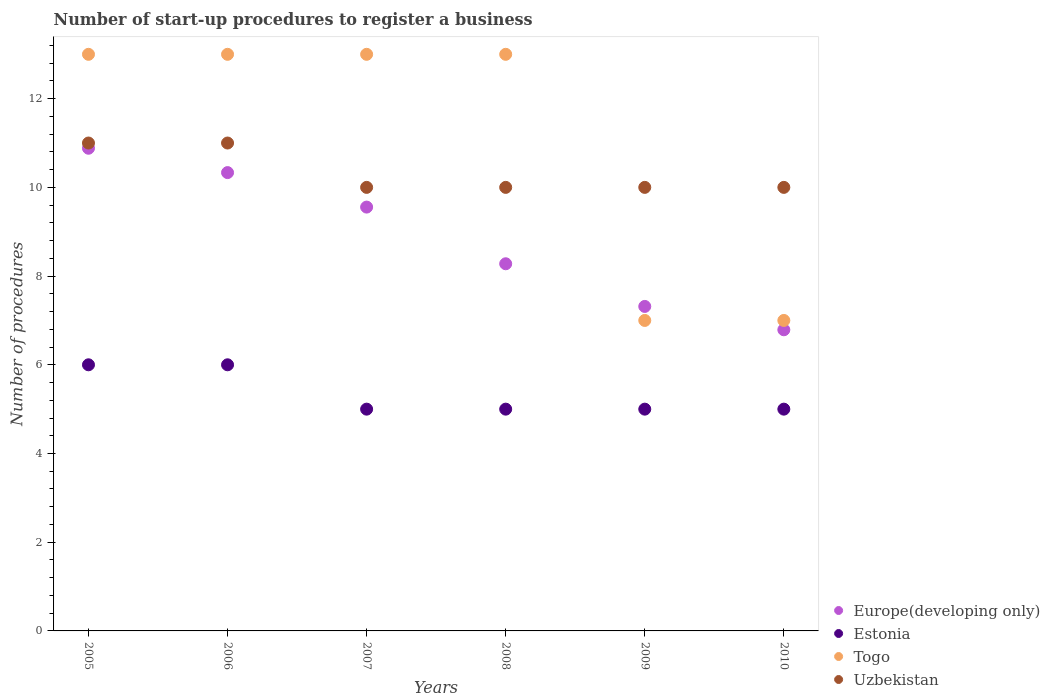Is the number of dotlines equal to the number of legend labels?
Keep it short and to the point. Yes. What is the number of procedures required to register a business in Uzbekistan in 2006?
Your answer should be compact. 11. Across all years, what is the maximum number of procedures required to register a business in Togo?
Your answer should be very brief. 13. Across all years, what is the minimum number of procedures required to register a business in Estonia?
Ensure brevity in your answer.  5. In which year was the number of procedures required to register a business in Uzbekistan maximum?
Keep it short and to the point. 2005. What is the total number of procedures required to register a business in Togo in the graph?
Give a very brief answer. 66. What is the difference between the number of procedures required to register a business in Estonia in 2008 and the number of procedures required to register a business in Europe(developing only) in 2007?
Offer a very short reply. -4.56. What is the average number of procedures required to register a business in Togo per year?
Provide a succinct answer. 11. In the year 2008, what is the difference between the number of procedures required to register a business in Togo and number of procedures required to register a business in Estonia?
Your response must be concise. 8. In how many years, is the number of procedures required to register a business in Europe(developing only) greater than 2.8?
Provide a succinct answer. 6. What is the ratio of the number of procedures required to register a business in Europe(developing only) in 2005 to that in 2008?
Give a very brief answer. 1.31. Is the number of procedures required to register a business in Estonia in 2008 less than that in 2009?
Provide a succinct answer. No. What is the difference between the highest and the second highest number of procedures required to register a business in Estonia?
Offer a very short reply. 0. What is the difference between the highest and the lowest number of procedures required to register a business in Europe(developing only)?
Make the answer very short. 4.09. Does the number of procedures required to register a business in Uzbekistan monotonically increase over the years?
Ensure brevity in your answer.  No. Is the number of procedures required to register a business in Togo strictly greater than the number of procedures required to register a business in Uzbekistan over the years?
Give a very brief answer. No. How many years are there in the graph?
Your response must be concise. 6. What is the difference between two consecutive major ticks on the Y-axis?
Offer a very short reply. 2. Are the values on the major ticks of Y-axis written in scientific E-notation?
Offer a very short reply. No. Where does the legend appear in the graph?
Your response must be concise. Bottom right. How many legend labels are there?
Keep it short and to the point. 4. What is the title of the graph?
Keep it short and to the point. Number of start-up procedures to register a business. Does "Faeroe Islands" appear as one of the legend labels in the graph?
Your answer should be very brief. No. What is the label or title of the X-axis?
Ensure brevity in your answer.  Years. What is the label or title of the Y-axis?
Your answer should be compact. Number of procedures. What is the Number of procedures of Europe(developing only) in 2005?
Provide a succinct answer. 10.88. What is the Number of procedures in Estonia in 2005?
Offer a terse response. 6. What is the Number of procedures of Uzbekistan in 2005?
Make the answer very short. 11. What is the Number of procedures of Europe(developing only) in 2006?
Offer a terse response. 10.33. What is the Number of procedures of Estonia in 2006?
Provide a succinct answer. 6. What is the Number of procedures in Uzbekistan in 2006?
Provide a succinct answer. 11. What is the Number of procedures of Europe(developing only) in 2007?
Offer a very short reply. 9.56. What is the Number of procedures in Estonia in 2007?
Ensure brevity in your answer.  5. What is the Number of procedures of Togo in 2007?
Offer a terse response. 13. What is the Number of procedures of Uzbekistan in 2007?
Keep it short and to the point. 10. What is the Number of procedures in Europe(developing only) in 2008?
Offer a terse response. 8.28. What is the Number of procedures in Europe(developing only) in 2009?
Provide a succinct answer. 7.32. What is the Number of procedures in Estonia in 2009?
Provide a succinct answer. 5. What is the Number of procedures of Togo in 2009?
Give a very brief answer. 7. What is the Number of procedures in Uzbekistan in 2009?
Offer a terse response. 10. What is the Number of procedures in Europe(developing only) in 2010?
Ensure brevity in your answer.  6.79. What is the Number of procedures in Estonia in 2010?
Your answer should be very brief. 5. What is the Number of procedures of Togo in 2010?
Keep it short and to the point. 7. Across all years, what is the maximum Number of procedures in Europe(developing only)?
Ensure brevity in your answer.  10.88. Across all years, what is the maximum Number of procedures in Estonia?
Offer a terse response. 6. Across all years, what is the maximum Number of procedures in Togo?
Keep it short and to the point. 13. Across all years, what is the minimum Number of procedures of Europe(developing only)?
Your answer should be compact. 6.79. Across all years, what is the minimum Number of procedures of Togo?
Provide a short and direct response. 7. What is the total Number of procedures of Europe(developing only) in the graph?
Keep it short and to the point. 53.15. What is the total Number of procedures of Togo in the graph?
Make the answer very short. 66. What is the difference between the Number of procedures of Europe(developing only) in 2005 and that in 2006?
Make the answer very short. 0.55. What is the difference between the Number of procedures of Estonia in 2005 and that in 2006?
Offer a very short reply. 0. What is the difference between the Number of procedures of Togo in 2005 and that in 2006?
Your response must be concise. 0. What is the difference between the Number of procedures of Europe(developing only) in 2005 and that in 2007?
Provide a short and direct response. 1.33. What is the difference between the Number of procedures of Europe(developing only) in 2005 and that in 2008?
Provide a short and direct response. 2.6. What is the difference between the Number of procedures in Togo in 2005 and that in 2008?
Your answer should be very brief. 0. What is the difference between the Number of procedures of Europe(developing only) in 2005 and that in 2009?
Your answer should be compact. 3.57. What is the difference between the Number of procedures in Uzbekistan in 2005 and that in 2009?
Offer a very short reply. 1. What is the difference between the Number of procedures of Europe(developing only) in 2005 and that in 2010?
Ensure brevity in your answer.  4.09. What is the difference between the Number of procedures of Uzbekistan in 2005 and that in 2010?
Give a very brief answer. 1. What is the difference between the Number of procedures of Togo in 2006 and that in 2007?
Give a very brief answer. 0. What is the difference between the Number of procedures of Uzbekistan in 2006 and that in 2007?
Make the answer very short. 1. What is the difference between the Number of procedures in Europe(developing only) in 2006 and that in 2008?
Your response must be concise. 2.06. What is the difference between the Number of procedures in Togo in 2006 and that in 2008?
Your answer should be very brief. 0. What is the difference between the Number of procedures of Europe(developing only) in 2006 and that in 2009?
Your response must be concise. 3.02. What is the difference between the Number of procedures of Estonia in 2006 and that in 2009?
Offer a very short reply. 1. What is the difference between the Number of procedures of Europe(developing only) in 2006 and that in 2010?
Offer a very short reply. 3.54. What is the difference between the Number of procedures of Togo in 2006 and that in 2010?
Offer a very short reply. 6. What is the difference between the Number of procedures in Europe(developing only) in 2007 and that in 2008?
Offer a very short reply. 1.28. What is the difference between the Number of procedures of Estonia in 2007 and that in 2008?
Offer a very short reply. 0. What is the difference between the Number of procedures of Uzbekistan in 2007 and that in 2008?
Provide a short and direct response. 0. What is the difference between the Number of procedures in Europe(developing only) in 2007 and that in 2009?
Give a very brief answer. 2.24. What is the difference between the Number of procedures of Uzbekistan in 2007 and that in 2009?
Make the answer very short. 0. What is the difference between the Number of procedures in Europe(developing only) in 2007 and that in 2010?
Your response must be concise. 2.77. What is the difference between the Number of procedures of Togo in 2007 and that in 2010?
Offer a very short reply. 6. What is the difference between the Number of procedures in Europe(developing only) in 2008 and that in 2009?
Offer a terse response. 0.96. What is the difference between the Number of procedures in Estonia in 2008 and that in 2009?
Offer a terse response. 0. What is the difference between the Number of procedures of Togo in 2008 and that in 2009?
Your answer should be compact. 6. What is the difference between the Number of procedures in Europe(developing only) in 2008 and that in 2010?
Keep it short and to the point. 1.49. What is the difference between the Number of procedures of Estonia in 2008 and that in 2010?
Offer a terse response. 0. What is the difference between the Number of procedures in Togo in 2008 and that in 2010?
Your response must be concise. 6. What is the difference between the Number of procedures in Uzbekistan in 2008 and that in 2010?
Provide a short and direct response. 0. What is the difference between the Number of procedures in Europe(developing only) in 2009 and that in 2010?
Provide a short and direct response. 0.53. What is the difference between the Number of procedures of Uzbekistan in 2009 and that in 2010?
Make the answer very short. 0. What is the difference between the Number of procedures in Europe(developing only) in 2005 and the Number of procedures in Estonia in 2006?
Offer a very short reply. 4.88. What is the difference between the Number of procedures in Europe(developing only) in 2005 and the Number of procedures in Togo in 2006?
Your answer should be compact. -2.12. What is the difference between the Number of procedures of Europe(developing only) in 2005 and the Number of procedures of Uzbekistan in 2006?
Keep it short and to the point. -0.12. What is the difference between the Number of procedures of Estonia in 2005 and the Number of procedures of Togo in 2006?
Offer a terse response. -7. What is the difference between the Number of procedures in Estonia in 2005 and the Number of procedures in Uzbekistan in 2006?
Ensure brevity in your answer.  -5. What is the difference between the Number of procedures in Togo in 2005 and the Number of procedures in Uzbekistan in 2006?
Provide a succinct answer. 2. What is the difference between the Number of procedures of Europe(developing only) in 2005 and the Number of procedures of Estonia in 2007?
Keep it short and to the point. 5.88. What is the difference between the Number of procedures in Europe(developing only) in 2005 and the Number of procedures in Togo in 2007?
Make the answer very short. -2.12. What is the difference between the Number of procedures in Europe(developing only) in 2005 and the Number of procedures in Uzbekistan in 2007?
Ensure brevity in your answer.  0.88. What is the difference between the Number of procedures of Estonia in 2005 and the Number of procedures of Uzbekistan in 2007?
Your answer should be very brief. -4. What is the difference between the Number of procedures of Togo in 2005 and the Number of procedures of Uzbekistan in 2007?
Your answer should be very brief. 3. What is the difference between the Number of procedures of Europe(developing only) in 2005 and the Number of procedures of Estonia in 2008?
Provide a succinct answer. 5.88. What is the difference between the Number of procedures of Europe(developing only) in 2005 and the Number of procedures of Togo in 2008?
Your response must be concise. -2.12. What is the difference between the Number of procedures of Europe(developing only) in 2005 and the Number of procedures of Uzbekistan in 2008?
Keep it short and to the point. 0.88. What is the difference between the Number of procedures in Estonia in 2005 and the Number of procedures in Togo in 2008?
Your response must be concise. -7. What is the difference between the Number of procedures of Estonia in 2005 and the Number of procedures of Uzbekistan in 2008?
Provide a short and direct response. -4. What is the difference between the Number of procedures in Togo in 2005 and the Number of procedures in Uzbekistan in 2008?
Your answer should be very brief. 3. What is the difference between the Number of procedures of Europe(developing only) in 2005 and the Number of procedures of Estonia in 2009?
Provide a short and direct response. 5.88. What is the difference between the Number of procedures in Europe(developing only) in 2005 and the Number of procedures in Togo in 2009?
Make the answer very short. 3.88. What is the difference between the Number of procedures in Europe(developing only) in 2005 and the Number of procedures in Uzbekistan in 2009?
Ensure brevity in your answer.  0.88. What is the difference between the Number of procedures in Estonia in 2005 and the Number of procedures in Togo in 2009?
Your answer should be compact. -1. What is the difference between the Number of procedures in Europe(developing only) in 2005 and the Number of procedures in Estonia in 2010?
Your response must be concise. 5.88. What is the difference between the Number of procedures in Europe(developing only) in 2005 and the Number of procedures in Togo in 2010?
Provide a succinct answer. 3.88. What is the difference between the Number of procedures of Europe(developing only) in 2005 and the Number of procedures of Uzbekistan in 2010?
Your answer should be compact. 0.88. What is the difference between the Number of procedures in Estonia in 2005 and the Number of procedures in Togo in 2010?
Offer a terse response. -1. What is the difference between the Number of procedures in Estonia in 2005 and the Number of procedures in Uzbekistan in 2010?
Offer a terse response. -4. What is the difference between the Number of procedures of Togo in 2005 and the Number of procedures of Uzbekistan in 2010?
Your answer should be compact. 3. What is the difference between the Number of procedures in Europe(developing only) in 2006 and the Number of procedures in Estonia in 2007?
Keep it short and to the point. 5.33. What is the difference between the Number of procedures of Europe(developing only) in 2006 and the Number of procedures of Togo in 2007?
Your response must be concise. -2.67. What is the difference between the Number of procedures of Estonia in 2006 and the Number of procedures of Uzbekistan in 2007?
Your answer should be compact. -4. What is the difference between the Number of procedures of Togo in 2006 and the Number of procedures of Uzbekistan in 2007?
Provide a short and direct response. 3. What is the difference between the Number of procedures in Europe(developing only) in 2006 and the Number of procedures in Estonia in 2008?
Make the answer very short. 5.33. What is the difference between the Number of procedures of Europe(developing only) in 2006 and the Number of procedures of Togo in 2008?
Ensure brevity in your answer.  -2.67. What is the difference between the Number of procedures in Estonia in 2006 and the Number of procedures in Togo in 2008?
Offer a very short reply. -7. What is the difference between the Number of procedures of Togo in 2006 and the Number of procedures of Uzbekistan in 2008?
Your response must be concise. 3. What is the difference between the Number of procedures of Europe(developing only) in 2006 and the Number of procedures of Estonia in 2009?
Provide a succinct answer. 5.33. What is the difference between the Number of procedures in Estonia in 2006 and the Number of procedures in Togo in 2009?
Offer a terse response. -1. What is the difference between the Number of procedures of Europe(developing only) in 2006 and the Number of procedures of Estonia in 2010?
Your answer should be very brief. 5.33. What is the difference between the Number of procedures of Europe(developing only) in 2006 and the Number of procedures of Uzbekistan in 2010?
Offer a terse response. 0.33. What is the difference between the Number of procedures of Estonia in 2006 and the Number of procedures of Togo in 2010?
Keep it short and to the point. -1. What is the difference between the Number of procedures of Europe(developing only) in 2007 and the Number of procedures of Estonia in 2008?
Give a very brief answer. 4.56. What is the difference between the Number of procedures of Europe(developing only) in 2007 and the Number of procedures of Togo in 2008?
Your answer should be very brief. -3.44. What is the difference between the Number of procedures in Europe(developing only) in 2007 and the Number of procedures in Uzbekistan in 2008?
Your answer should be compact. -0.44. What is the difference between the Number of procedures of Estonia in 2007 and the Number of procedures of Togo in 2008?
Ensure brevity in your answer.  -8. What is the difference between the Number of procedures of Estonia in 2007 and the Number of procedures of Uzbekistan in 2008?
Provide a succinct answer. -5. What is the difference between the Number of procedures in Europe(developing only) in 2007 and the Number of procedures in Estonia in 2009?
Your answer should be compact. 4.56. What is the difference between the Number of procedures in Europe(developing only) in 2007 and the Number of procedures in Togo in 2009?
Offer a very short reply. 2.56. What is the difference between the Number of procedures in Europe(developing only) in 2007 and the Number of procedures in Uzbekistan in 2009?
Provide a succinct answer. -0.44. What is the difference between the Number of procedures of Estonia in 2007 and the Number of procedures of Uzbekistan in 2009?
Your answer should be compact. -5. What is the difference between the Number of procedures in Europe(developing only) in 2007 and the Number of procedures in Estonia in 2010?
Your response must be concise. 4.56. What is the difference between the Number of procedures of Europe(developing only) in 2007 and the Number of procedures of Togo in 2010?
Offer a very short reply. 2.56. What is the difference between the Number of procedures in Europe(developing only) in 2007 and the Number of procedures in Uzbekistan in 2010?
Your response must be concise. -0.44. What is the difference between the Number of procedures in Estonia in 2007 and the Number of procedures in Togo in 2010?
Give a very brief answer. -2. What is the difference between the Number of procedures of Togo in 2007 and the Number of procedures of Uzbekistan in 2010?
Offer a terse response. 3. What is the difference between the Number of procedures in Europe(developing only) in 2008 and the Number of procedures in Estonia in 2009?
Your answer should be very brief. 3.28. What is the difference between the Number of procedures of Europe(developing only) in 2008 and the Number of procedures of Togo in 2009?
Provide a short and direct response. 1.28. What is the difference between the Number of procedures of Europe(developing only) in 2008 and the Number of procedures of Uzbekistan in 2009?
Your answer should be compact. -1.72. What is the difference between the Number of procedures of Estonia in 2008 and the Number of procedures of Uzbekistan in 2009?
Make the answer very short. -5. What is the difference between the Number of procedures in Togo in 2008 and the Number of procedures in Uzbekistan in 2009?
Make the answer very short. 3. What is the difference between the Number of procedures of Europe(developing only) in 2008 and the Number of procedures of Estonia in 2010?
Your answer should be compact. 3.28. What is the difference between the Number of procedures of Europe(developing only) in 2008 and the Number of procedures of Togo in 2010?
Your answer should be compact. 1.28. What is the difference between the Number of procedures of Europe(developing only) in 2008 and the Number of procedures of Uzbekistan in 2010?
Your answer should be compact. -1.72. What is the difference between the Number of procedures of Estonia in 2008 and the Number of procedures of Togo in 2010?
Keep it short and to the point. -2. What is the difference between the Number of procedures in Togo in 2008 and the Number of procedures in Uzbekistan in 2010?
Provide a succinct answer. 3. What is the difference between the Number of procedures in Europe(developing only) in 2009 and the Number of procedures in Estonia in 2010?
Your answer should be very brief. 2.32. What is the difference between the Number of procedures of Europe(developing only) in 2009 and the Number of procedures of Togo in 2010?
Keep it short and to the point. 0.32. What is the difference between the Number of procedures in Europe(developing only) in 2009 and the Number of procedures in Uzbekistan in 2010?
Provide a succinct answer. -2.68. What is the difference between the Number of procedures in Estonia in 2009 and the Number of procedures in Togo in 2010?
Make the answer very short. -2. What is the difference between the Number of procedures in Estonia in 2009 and the Number of procedures in Uzbekistan in 2010?
Offer a very short reply. -5. What is the difference between the Number of procedures of Togo in 2009 and the Number of procedures of Uzbekistan in 2010?
Provide a short and direct response. -3. What is the average Number of procedures of Europe(developing only) per year?
Your answer should be very brief. 8.86. What is the average Number of procedures in Estonia per year?
Keep it short and to the point. 5.33. What is the average Number of procedures in Uzbekistan per year?
Your answer should be very brief. 10.33. In the year 2005, what is the difference between the Number of procedures in Europe(developing only) and Number of procedures in Estonia?
Your answer should be compact. 4.88. In the year 2005, what is the difference between the Number of procedures of Europe(developing only) and Number of procedures of Togo?
Keep it short and to the point. -2.12. In the year 2005, what is the difference between the Number of procedures in Europe(developing only) and Number of procedures in Uzbekistan?
Ensure brevity in your answer.  -0.12. In the year 2005, what is the difference between the Number of procedures of Estonia and Number of procedures of Togo?
Your answer should be compact. -7. In the year 2005, what is the difference between the Number of procedures in Togo and Number of procedures in Uzbekistan?
Provide a succinct answer. 2. In the year 2006, what is the difference between the Number of procedures of Europe(developing only) and Number of procedures of Estonia?
Offer a very short reply. 4.33. In the year 2006, what is the difference between the Number of procedures in Europe(developing only) and Number of procedures in Togo?
Your answer should be compact. -2.67. In the year 2006, what is the difference between the Number of procedures in Estonia and Number of procedures in Togo?
Provide a short and direct response. -7. In the year 2006, what is the difference between the Number of procedures of Estonia and Number of procedures of Uzbekistan?
Offer a terse response. -5. In the year 2006, what is the difference between the Number of procedures of Togo and Number of procedures of Uzbekistan?
Ensure brevity in your answer.  2. In the year 2007, what is the difference between the Number of procedures of Europe(developing only) and Number of procedures of Estonia?
Your answer should be compact. 4.56. In the year 2007, what is the difference between the Number of procedures in Europe(developing only) and Number of procedures in Togo?
Keep it short and to the point. -3.44. In the year 2007, what is the difference between the Number of procedures in Europe(developing only) and Number of procedures in Uzbekistan?
Provide a succinct answer. -0.44. In the year 2008, what is the difference between the Number of procedures of Europe(developing only) and Number of procedures of Estonia?
Ensure brevity in your answer.  3.28. In the year 2008, what is the difference between the Number of procedures in Europe(developing only) and Number of procedures in Togo?
Your answer should be compact. -4.72. In the year 2008, what is the difference between the Number of procedures of Europe(developing only) and Number of procedures of Uzbekistan?
Offer a very short reply. -1.72. In the year 2008, what is the difference between the Number of procedures of Estonia and Number of procedures of Togo?
Your answer should be compact. -8. In the year 2008, what is the difference between the Number of procedures in Togo and Number of procedures in Uzbekistan?
Provide a short and direct response. 3. In the year 2009, what is the difference between the Number of procedures of Europe(developing only) and Number of procedures of Estonia?
Your answer should be compact. 2.32. In the year 2009, what is the difference between the Number of procedures of Europe(developing only) and Number of procedures of Togo?
Your answer should be compact. 0.32. In the year 2009, what is the difference between the Number of procedures in Europe(developing only) and Number of procedures in Uzbekistan?
Provide a short and direct response. -2.68. In the year 2009, what is the difference between the Number of procedures of Estonia and Number of procedures of Uzbekistan?
Offer a very short reply. -5. In the year 2009, what is the difference between the Number of procedures in Togo and Number of procedures in Uzbekistan?
Provide a succinct answer. -3. In the year 2010, what is the difference between the Number of procedures in Europe(developing only) and Number of procedures in Estonia?
Make the answer very short. 1.79. In the year 2010, what is the difference between the Number of procedures of Europe(developing only) and Number of procedures of Togo?
Provide a succinct answer. -0.21. In the year 2010, what is the difference between the Number of procedures of Europe(developing only) and Number of procedures of Uzbekistan?
Your response must be concise. -3.21. In the year 2010, what is the difference between the Number of procedures in Estonia and Number of procedures in Togo?
Your response must be concise. -2. What is the ratio of the Number of procedures in Europe(developing only) in 2005 to that in 2006?
Offer a terse response. 1.05. What is the ratio of the Number of procedures in Togo in 2005 to that in 2006?
Offer a terse response. 1. What is the ratio of the Number of procedures of Uzbekistan in 2005 to that in 2006?
Your answer should be compact. 1. What is the ratio of the Number of procedures of Europe(developing only) in 2005 to that in 2007?
Your response must be concise. 1.14. What is the ratio of the Number of procedures of Europe(developing only) in 2005 to that in 2008?
Your answer should be compact. 1.31. What is the ratio of the Number of procedures in Europe(developing only) in 2005 to that in 2009?
Keep it short and to the point. 1.49. What is the ratio of the Number of procedures in Togo in 2005 to that in 2009?
Provide a short and direct response. 1.86. What is the ratio of the Number of procedures in Uzbekistan in 2005 to that in 2009?
Your answer should be compact. 1.1. What is the ratio of the Number of procedures of Europe(developing only) in 2005 to that in 2010?
Your answer should be very brief. 1.6. What is the ratio of the Number of procedures in Togo in 2005 to that in 2010?
Give a very brief answer. 1.86. What is the ratio of the Number of procedures of Uzbekistan in 2005 to that in 2010?
Provide a short and direct response. 1.1. What is the ratio of the Number of procedures in Europe(developing only) in 2006 to that in 2007?
Your response must be concise. 1.08. What is the ratio of the Number of procedures of Estonia in 2006 to that in 2007?
Provide a succinct answer. 1.2. What is the ratio of the Number of procedures in Uzbekistan in 2006 to that in 2007?
Your answer should be compact. 1.1. What is the ratio of the Number of procedures in Europe(developing only) in 2006 to that in 2008?
Your response must be concise. 1.25. What is the ratio of the Number of procedures in Europe(developing only) in 2006 to that in 2009?
Your response must be concise. 1.41. What is the ratio of the Number of procedures in Togo in 2006 to that in 2009?
Your answer should be compact. 1.86. What is the ratio of the Number of procedures of Uzbekistan in 2006 to that in 2009?
Offer a terse response. 1.1. What is the ratio of the Number of procedures of Europe(developing only) in 2006 to that in 2010?
Your answer should be very brief. 1.52. What is the ratio of the Number of procedures of Togo in 2006 to that in 2010?
Make the answer very short. 1.86. What is the ratio of the Number of procedures in Uzbekistan in 2006 to that in 2010?
Provide a short and direct response. 1.1. What is the ratio of the Number of procedures in Europe(developing only) in 2007 to that in 2008?
Keep it short and to the point. 1.15. What is the ratio of the Number of procedures in Estonia in 2007 to that in 2008?
Make the answer very short. 1. What is the ratio of the Number of procedures of Europe(developing only) in 2007 to that in 2009?
Give a very brief answer. 1.31. What is the ratio of the Number of procedures of Togo in 2007 to that in 2009?
Keep it short and to the point. 1.86. What is the ratio of the Number of procedures in Europe(developing only) in 2007 to that in 2010?
Make the answer very short. 1.41. What is the ratio of the Number of procedures of Togo in 2007 to that in 2010?
Your response must be concise. 1.86. What is the ratio of the Number of procedures of Europe(developing only) in 2008 to that in 2009?
Offer a terse response. 1.13. What is the ratio of the Number of procedures in Togo in 2008 to that in 2009?
Keep it short and to the point. 1.86. What is the ratio of the Number of procedures of Uzbekistan in 2008 to that in 2009?
Ensure brevity in your answer.  1. What is the ratio of the Number of procedures in Europe(developing only) in 2008 to that in 2010?
Your response must be concise. 1.22. What is the ratio of the Number of procedures in Togo in 2008 to that in 2010?
Make the answer very short. 1.86. What is the ratio of the Number of procedures in Europe(developing only) in 2009 to that in 2010?
Give a very brief answer. 1.08. What is the ratio of the Number of procedures of Estonia in 2009 to that in 2010?
Your answer should be very brief. 1. What is the ratio of the Number of procedures in Uzbekistan in 2009 to that in 2010?
Ensure brevity in your answer.  1. What is the difference between the highest and the second highest Number of procedures of Europe(developing only)?
Ensure brevity in your answer.  0.55. What is the difference between the highest and the second highest Number of procedures in Estonia?
Offer a terse response. 0. What is the difference between the highest and the second highest Number of procedures in Uzbekistan?
Offer a terse response. 0. What is the difference between the highest and the lowest Number of procedures of Europe(developing only)?
Offer a terse response. 4.09. What is the difference between the highest and the lowest Number of procedures in Estonia?
Provide a short and direct response. 1. What is the difference between the highest and the lowest Number of procedures in Uzbekistan?
Your response must be concise. 1. 